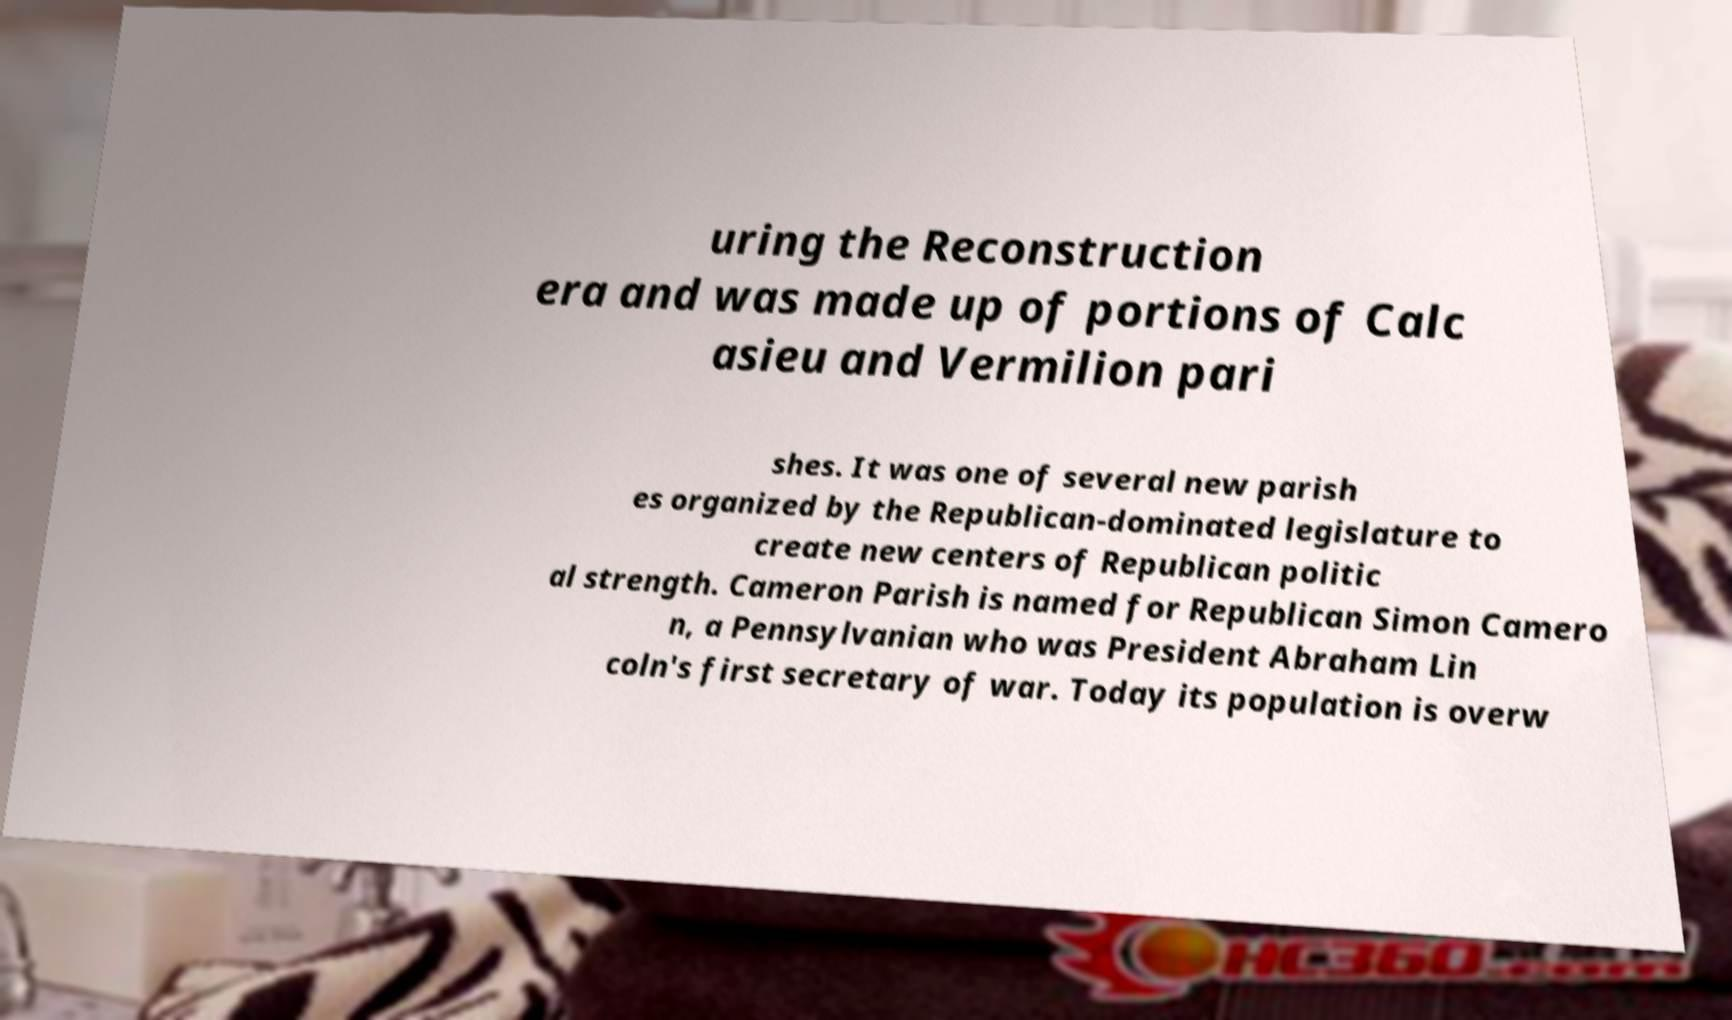What messages or text are displayed in this image? I need them in a readable, typed format. uring the Reconstruction era and was made up of portions of Calc asieu and Vermilion pari shes. It was one of several new parish es organized by the Republican-dominated legislature to create new centers of Republican politic al strength. Cameron Parish is named for Republican Simon Camero n, a Pennsylvanian who was President Abraham Lin coln's first secretary of war. Today its population is overw 